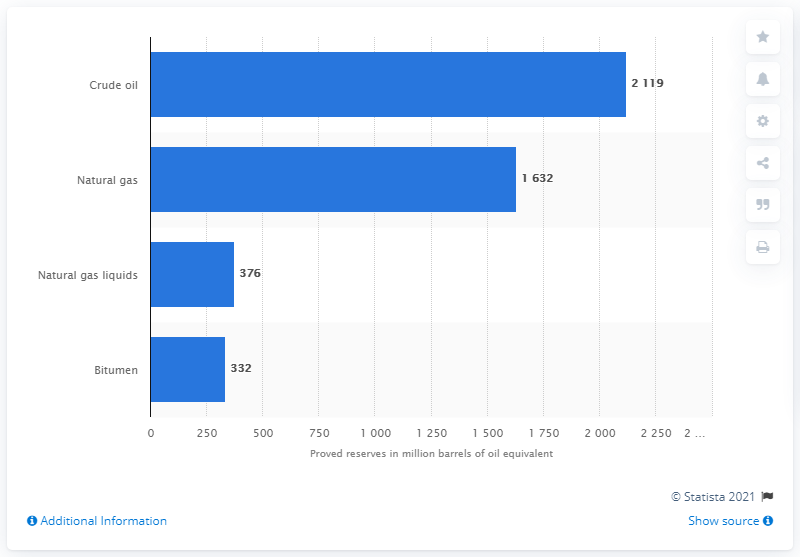Outline some significant characteristics in this image. In 2020, ConocoPhillips had a significant amount of crude oil. 